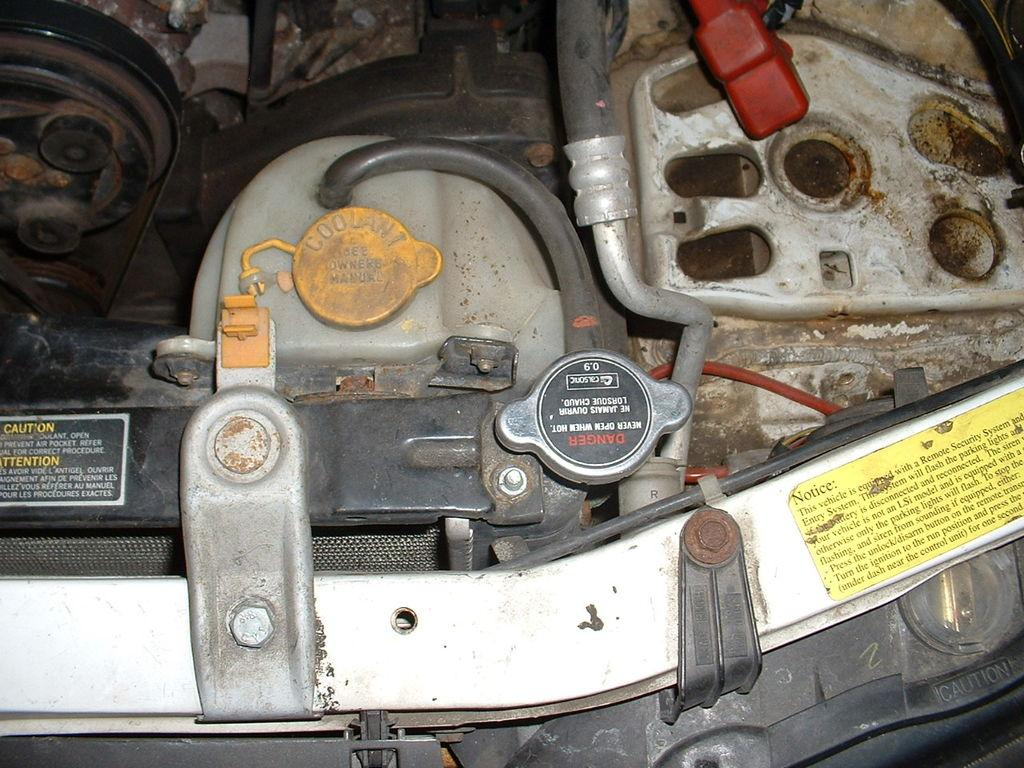What type of subject is depicted in the image? The image contains internal parts of a vehicle. Can you describe any specific components visible in the image? Unfortunately, without more specific information about the vehicle or its components, it is difficult to provide a detailed description. How often do the internal parts of the vehicle need to be sorted in the image? There is no indication in the image that the internal parts need to be sorted, as the image is a static representation of the components. 